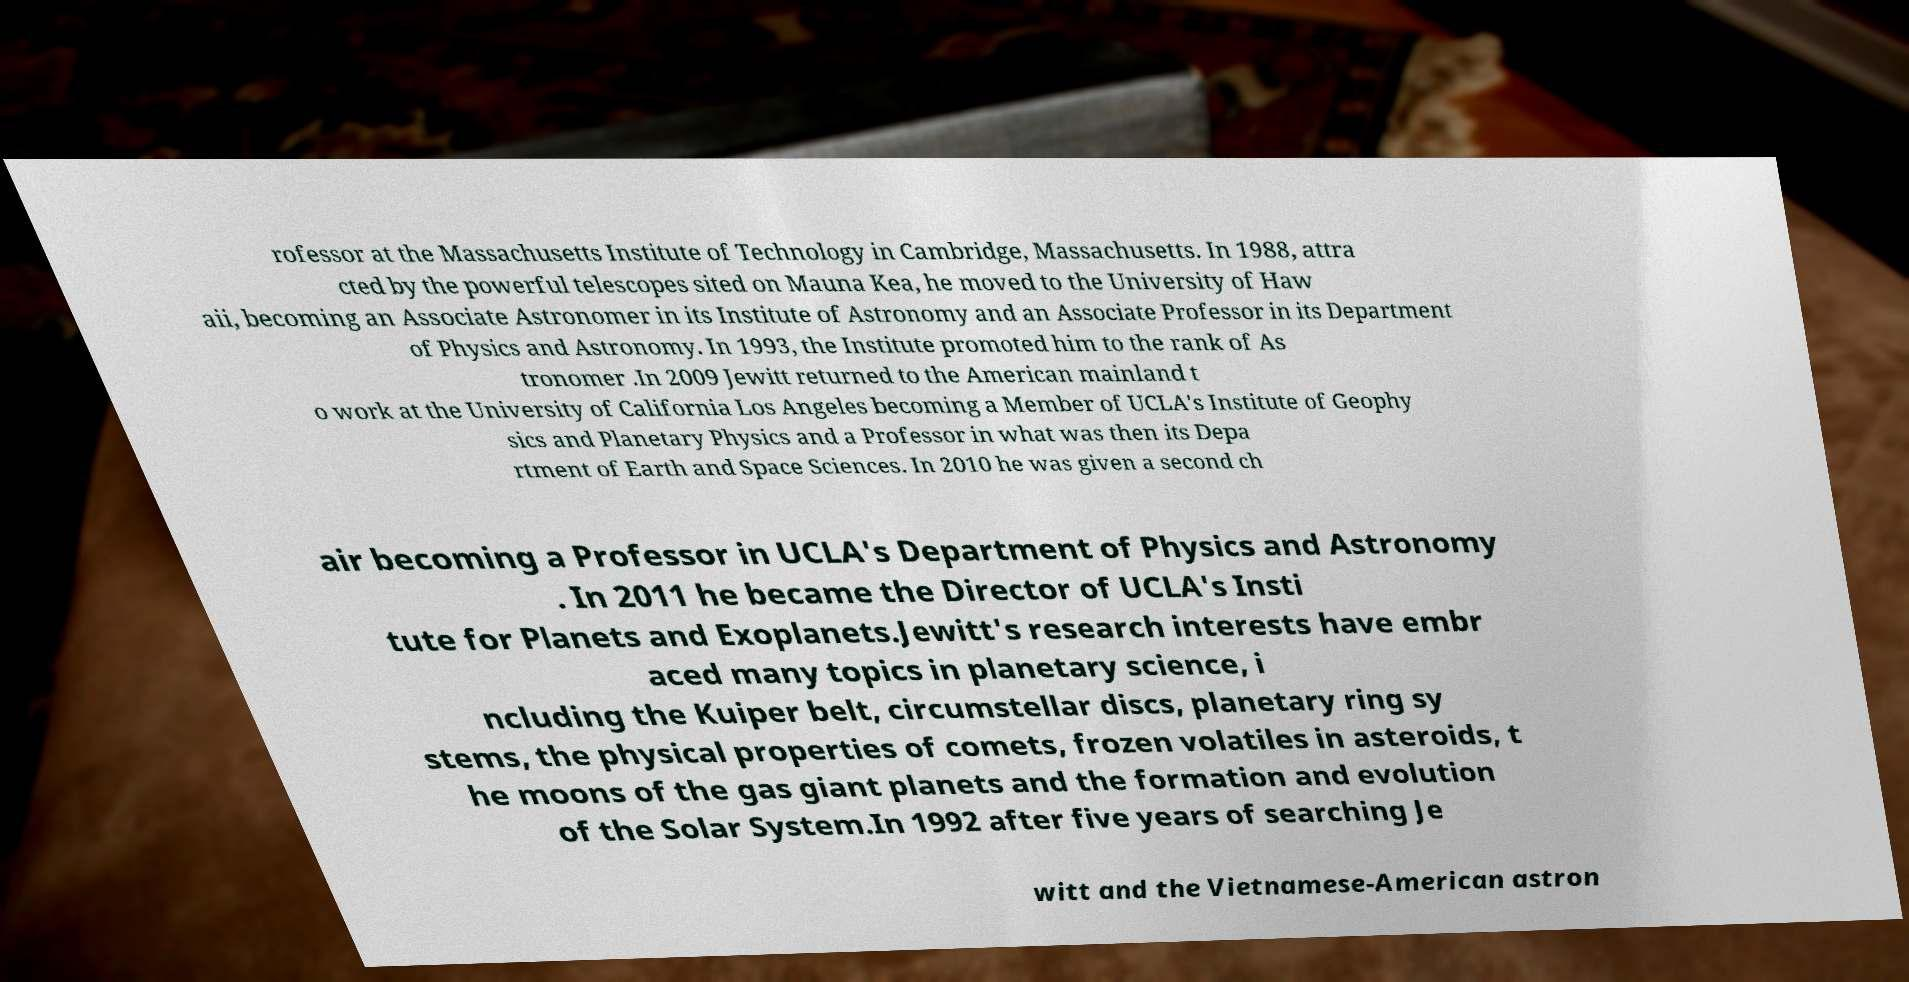Could you assist in decoding the text presented in this image and type it out clearly? rofessor at the Massachusetts Institute of Technology in Cambridge, Massachusetts. In 1988, attra cted by the powerful telescopes sited on Mauna Kea, he moved to the University of Haw aii, becoming an Associate Astronomer in its Institute of Astronomy and an Associate Professor in its Department of Physics and Astronomy. In 1993, the Institute promoted him to the rank of As tronomer .In 2009 Jewitt returned to the American mainland t o work at the University of California Los Angeles becoming a Member of UCLA's Institute of Geophy sics and Planetary Physics and a Professor in what was then its Depa rtment of Earth and Space Sciences. In 2010 he was given a second ch air becoming a Professor in UCLA's Department of Physics and Astronomy . In 2011 he became the Director of UCLA's Insti tute for Planets and Exoplanets.Jewitt's research interests have embr aced many topics in planetary science, i ncluding the Kuiper belt, circumstellar discs, planetary ring sy stems, the physical properties of comets, frozen volatiles in asteroids, t he moons of the gas giant planets and the formation and evolution of the Solar System.In 1992 after five years of searching Je witt and the Vietnamese-American astron 